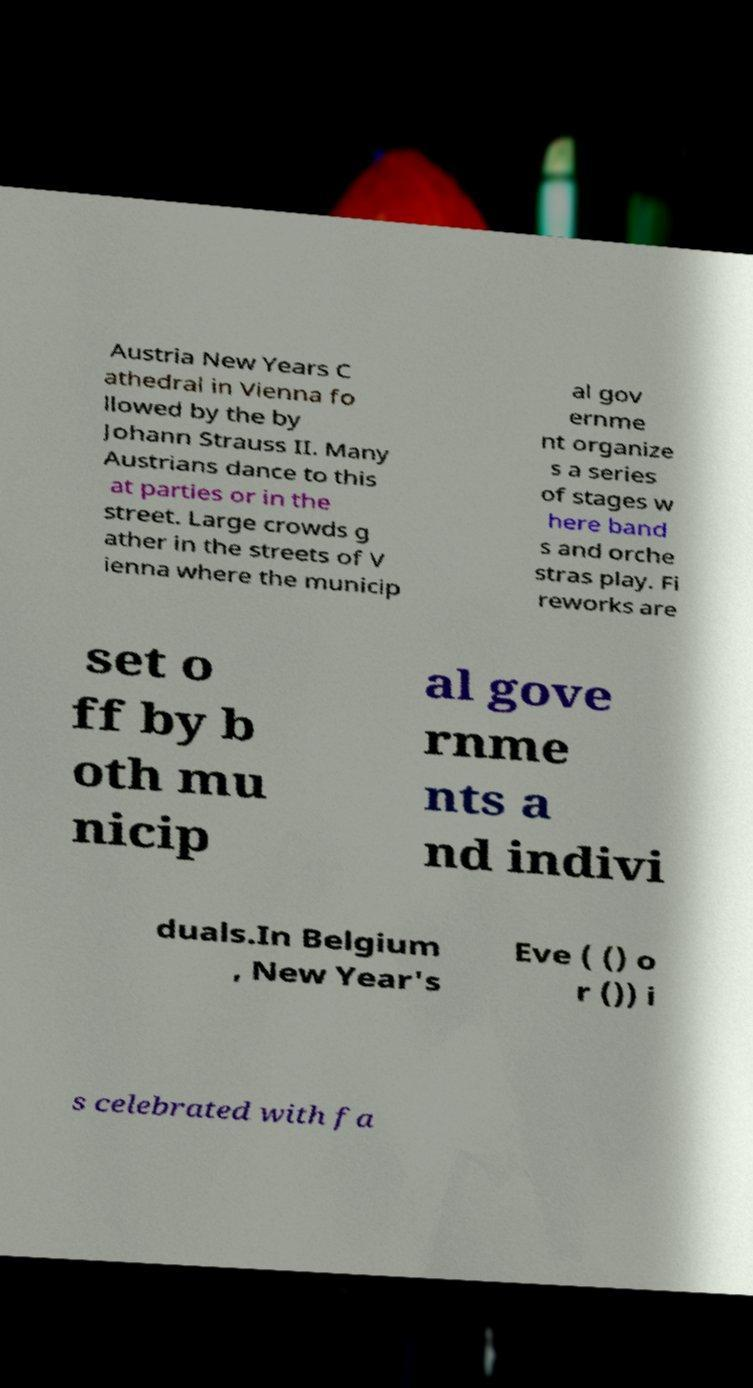For documentation purposes, I need the text within this image transcribed. Could you provide that? Austria New Years C athedral in Vienna fo llowed by the by Johann Strauss II. Many Austrians dance to this at parties or in the street. Large crowds g ather in the streets of V ienna where the municip al gov ernme nt organize s a series of stages w here band s and orche stras play. Fi reworks are set o ff by b oth mu nicip al gove rnme nts a nd indivi duals.In Belgium , New Year's Eve ( () o r ()) i s celebrated with fa 